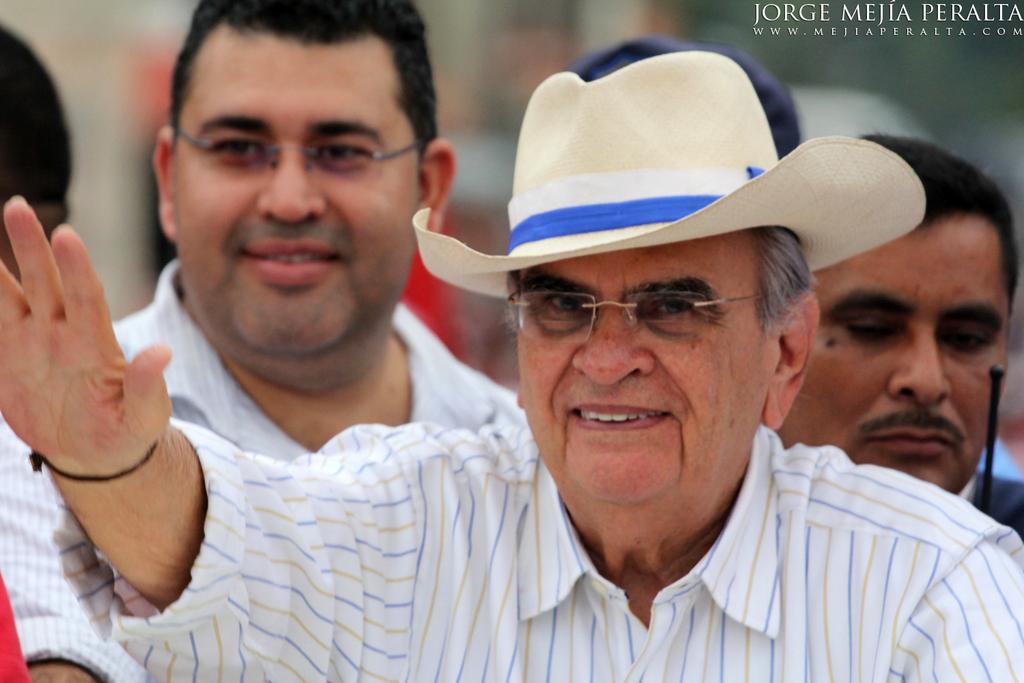Could you give a brief overview of what you see in this image? There is a group of persons standing as we can see in the middle of this image. The person standing at the bottom is wearing a white color cap. There is some text at the top right corner of this image. 